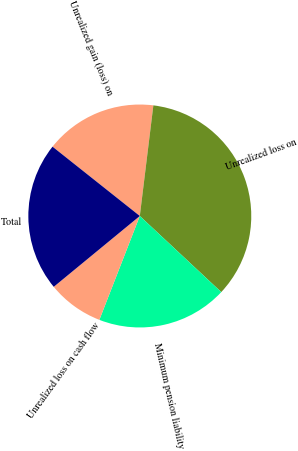Convert chart to OTSL. <chart><loc_0><loc_0><loc_500><loc_500><pie_chart><fcel>Unrealized gain (loss) on<fcel>Unrealized loss on<fcel>Minimum pension liability<fcel>Unrealized loss on cash flow<fcel>Total<nl><fcel>16.26%<fcel>35.02%<fcel>18.95%<fcel>8.13%<fcel>21.64%<nl></chart> 